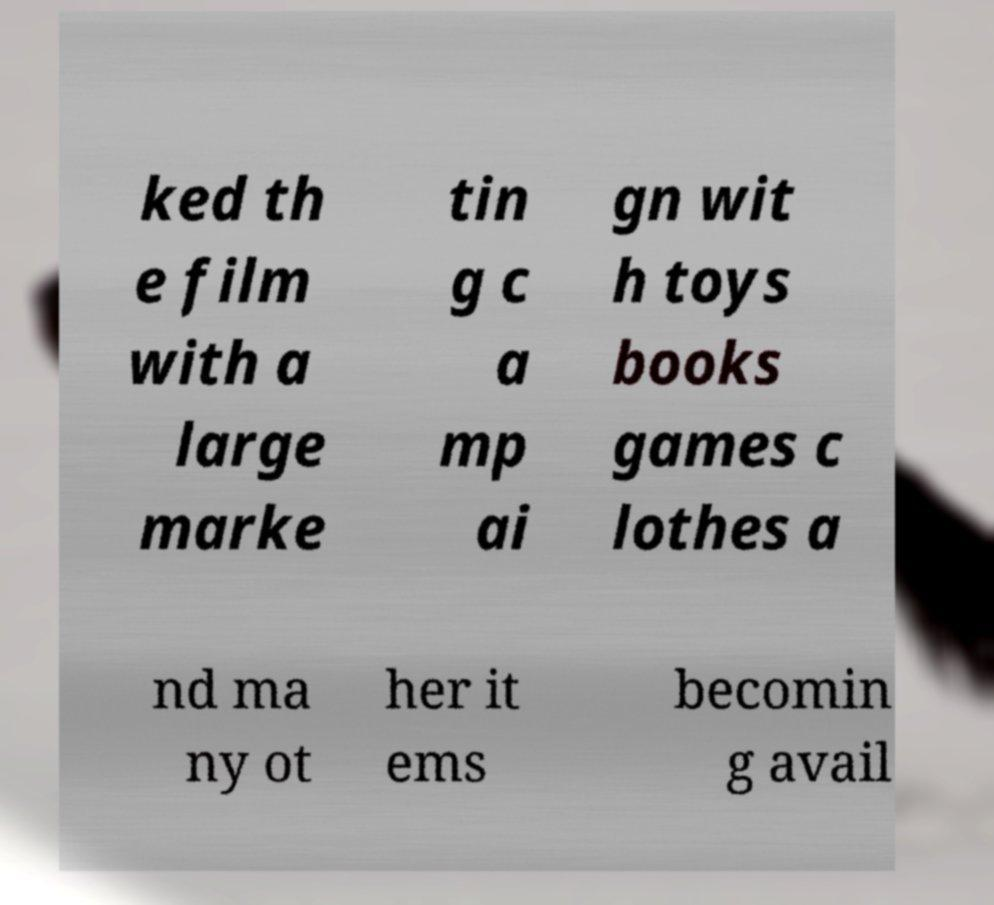Please read and relay the text visible in this image. What does it say? ked th e film with a large marke tin g c a mp ai gn wit h toys books games c lothes a nd ma ny ot her it ems becomin g avail 